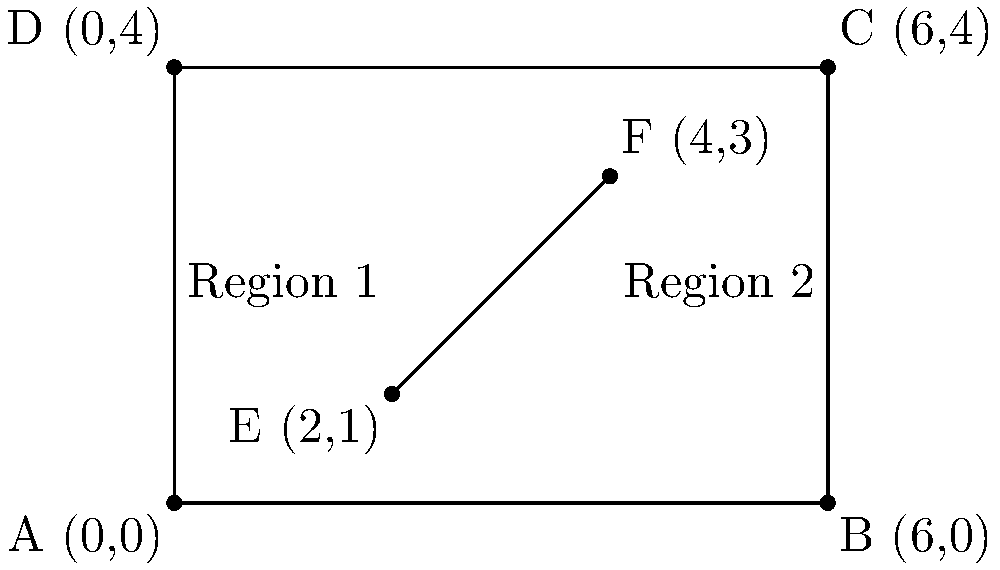A public health campaign is planning to cover two rectangular regions in a city. The city is represented on a coordinate system where each unit represents 1 km. Region 1 is bounded by the points A(0,0), D(0,4), E(2,1), and (2,0). Region 2 is bounded by the points (2,4), C(6,4), B(6,0), and F(4,3). Calculate the total area (in km²) that will be covered by the campaign. To solve this problem, we need to calculate the areas of both regions and sum them up:

1. Calculate the area of Region 1:
   - It's a trapezoid with bases of 2 km and 4 km, and a height of 2 km.
   - Area of a trapezoid = $\frac{1}{2}(b_1 + b_2)h$
   - Area of Region 1 = $\frac{1}{2}(2 + 4) \times 2 = 6$ km²

2. Calculate the area of Region 2:
   - It's also a trapezoid with bases of 4 km and 2 km, and a height of 4 km.
   - Area of Region 2 = $\frac{1}{2}(4 + 2) \times 4 = 12$ km²

3. Sum up the areas:
   Total area = Area of Region 1 + Area of Region 2
               = $6 + 12 = 18$ km²

Therefore, the total area covered by the public health campaign will be 18 km².
Answer: 18 km² 